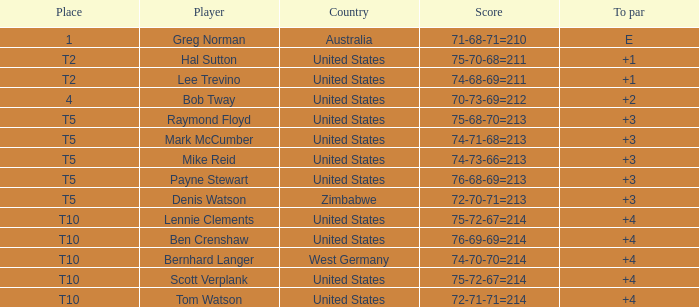Who is the player with a 75-68-70=213 score? Raymond Floyd. 